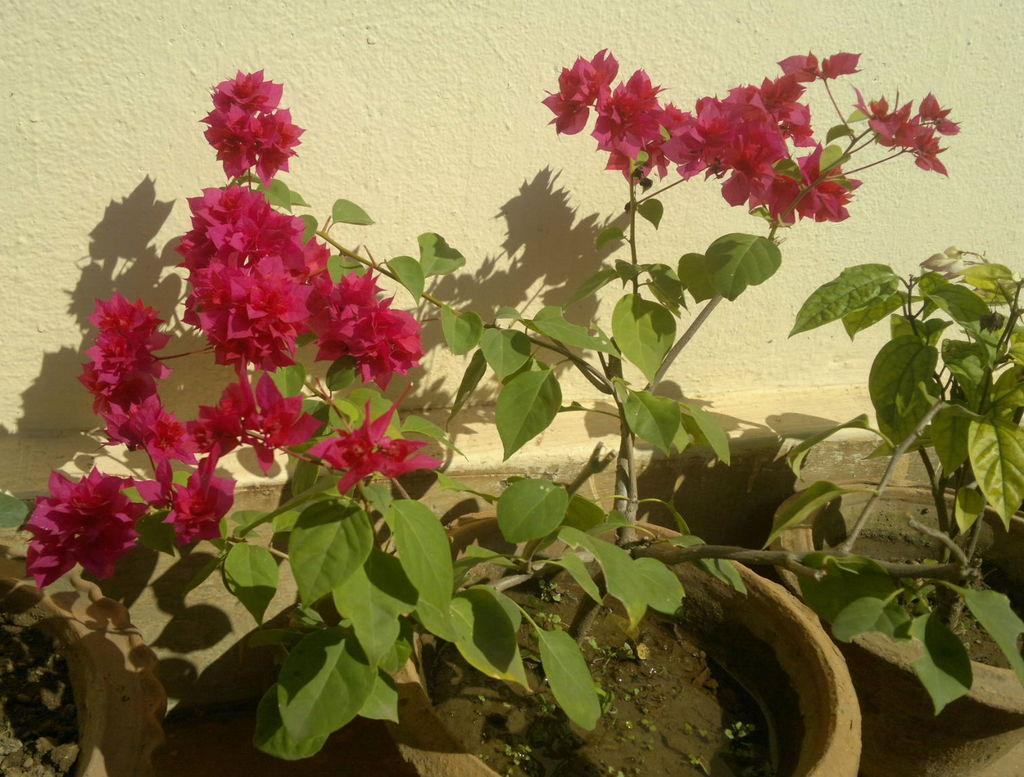What objects are present in the image? There are flower pots in the image. What can be seen in the background of the image? There is a wall in the background of the image. Is the temperature in the image hot enough to cause the flowers to wilt? The provided facts do not mention the temperature or the condition of the flowers, so it cannot be determined from the image. 